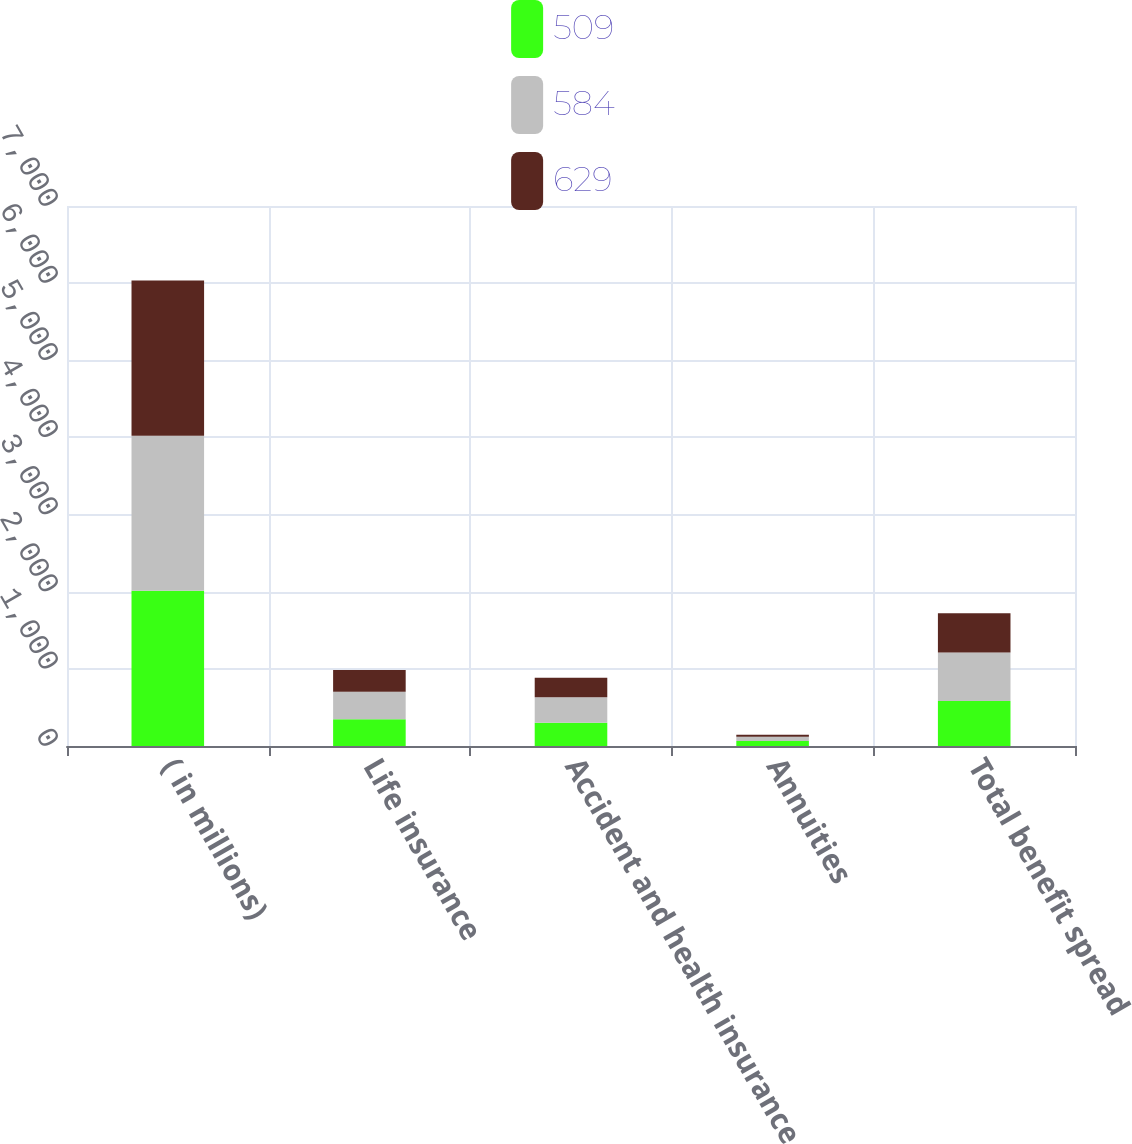<chart> <loc_0><loc_0><loc_500><loc_500><stacked_bar_chart><ecel><fcel>( in millions)<fcel>Life insurance<fcel>Accident and health insurance<fcel>Annuities<fcel>Total benefit spread<nl><fcel>509<fcel>2012<fcel>347<fcel>303<fcel>66<fcel>584<nl><fcel>584<fcel>2011<fcel>355<fcel>329<fcel>55<fcel>629<nl><fcel>629<fcel>2010<fcel>282<fcel>252<fcel>25<fcel>509<nl></chart> 